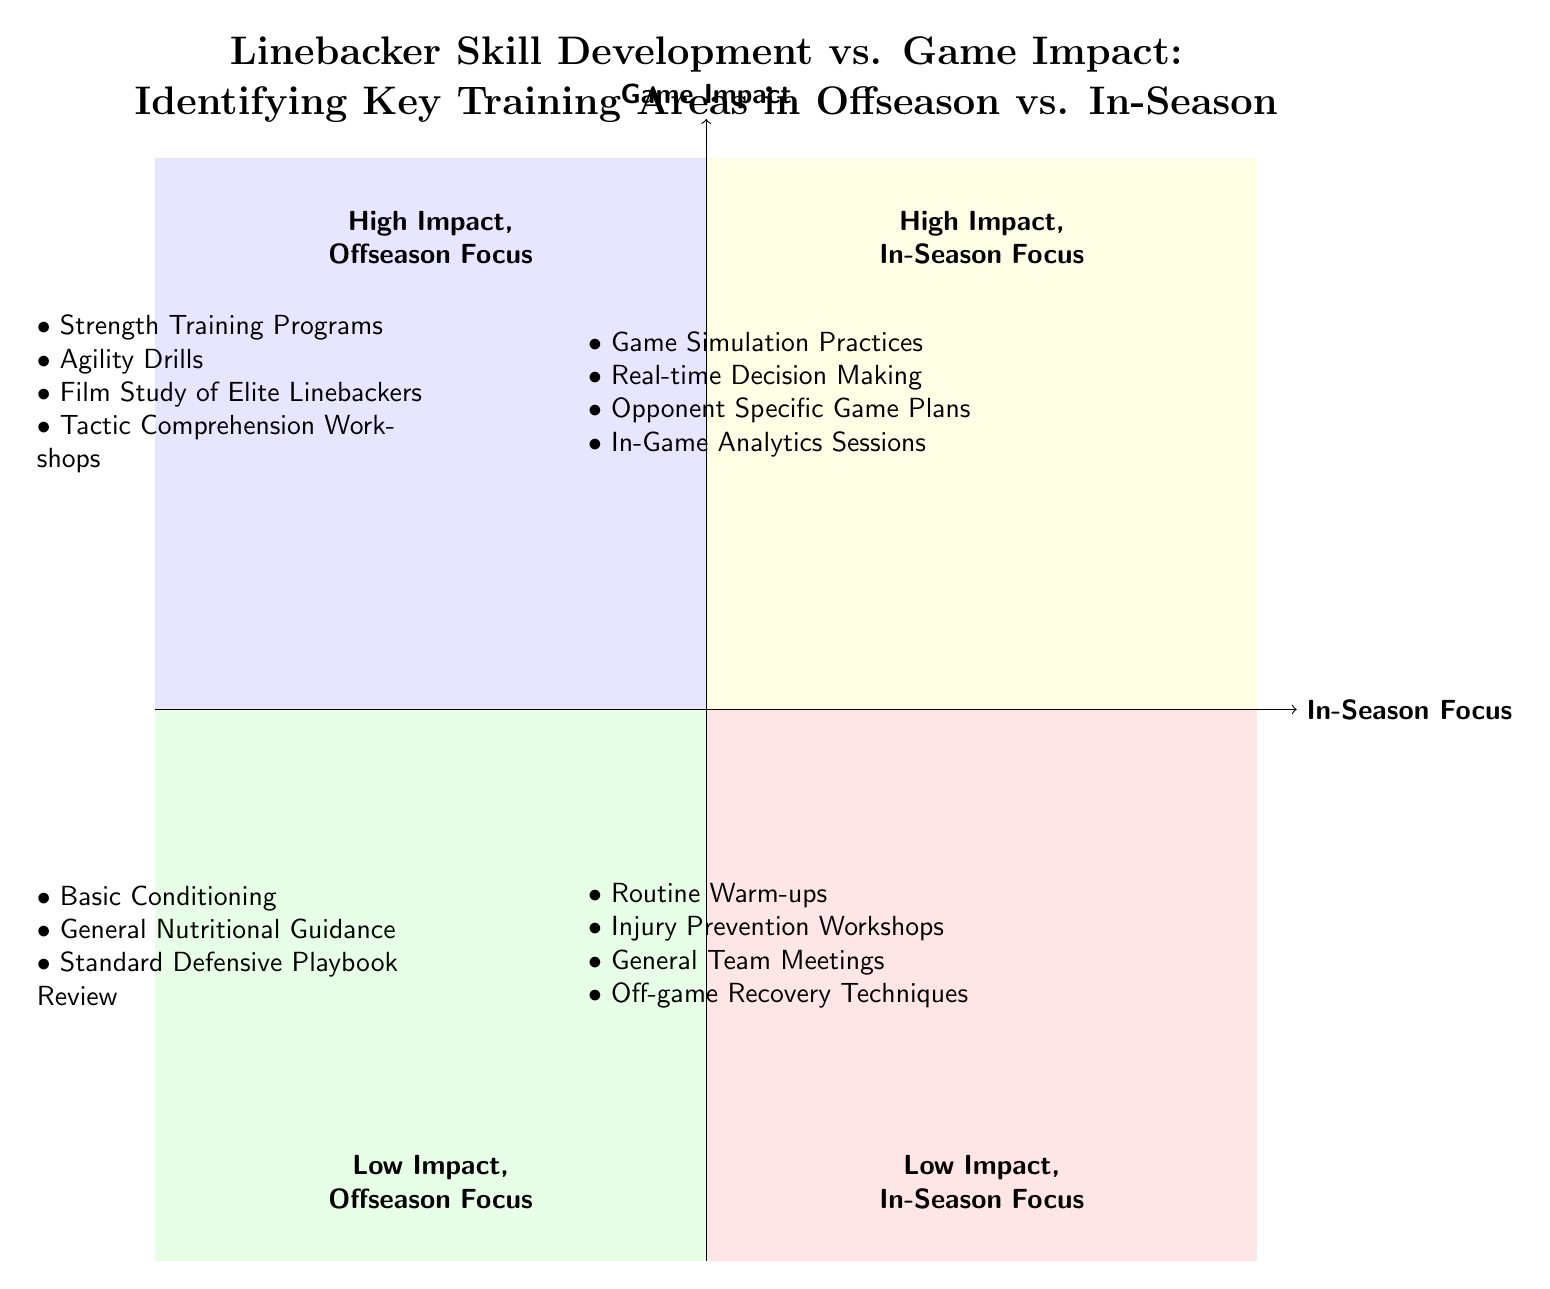What elements are included in the High Impact, Offseason Focus quadrant? The High Impact, Offseason Focus quadrant contains four elements: Strength Training Programs, Agility Drills, Film Study of Elite Linebackers, and Tactic Comprehension Workshops.
Answer: Strength Training Programs, Agility Drills, Film Study of Elite Linebackers, Tactic Comprehension Workshops How many elements are listed in the Low Impact, In-Season Focus quadrant? The Low Impact, In-Season Focus quadrant has four elements listed, which are Routine Warm-ups, Injury Prevention Workshops, General Team Meetings, and Off-game Recovery Techniques.
Answer: 4 Which focus has Game Simulation Practices as a key training area? Game Simulation Practices is listed under the High Impact, In-Season Focus quadrant, indicating that it is a key training area during the season.
Answer: High Impact, In-Season Focus What is the primary difference between the quadrants focused on Offseason and In-Season? The primary difference lies in the training focus; Offseason quadrants emphasize skill development, while In-Season quadrants emphasize real-time game impact and strategy execution.
Answer: Training focus How many High Impact training areas are identified across both Offseason and In-Season quadrants? There are a total of eight High Impact training areas, with four each from the High Impact, Offseason Focus and High Impact, In-Season Focus quadrants.
Answer: 8 Which quadrant contains elements related to injury prevention? The elements related to injury prevention are found in the Low Impact, In-Season Focus quadrant, specifically in the Injury Prevention Workshops.
Answer: Low Impact, In-Season Focus Are Agility Drills considered a Low Impact training area? No, Agility Drills are categorized under the High Impact, Offseason Focus quadrant, indicating they are significant training areas rather than low impact.
Answer: No What type of practice is emphasized in the High Impact, In-Season Focus quadrant? The High Impact, In-Season Focus quadrant emphasizes techniques like Game Simulation Practices and Real-time Decision Making to enhance the game impact during the season.
Answer: Game Simulation Practices Which quadrant focuses on Basic Conditioning? Basic Conditioning is located in the Low Impact, Offseason Focus quadrant, suggesting it is considered less impactful compared to other offseason training strategies.
Answer: Low Impact, Offseason Focus 